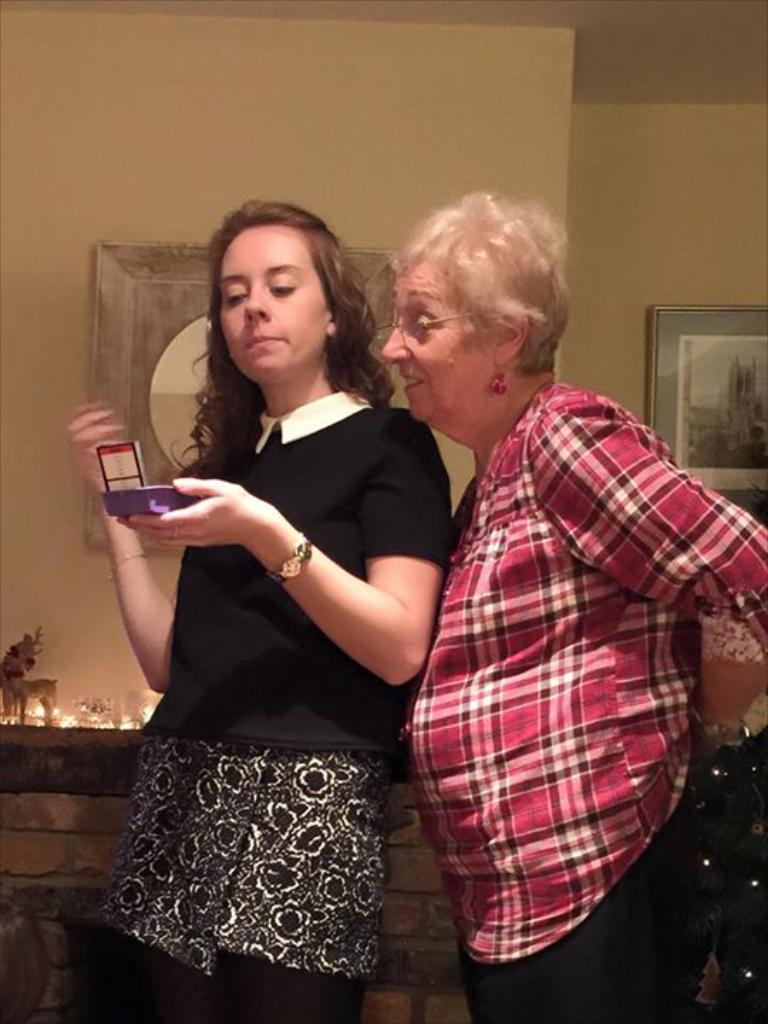How would you summarize this image in a sentence or two? Here we can see two women and she is holding an object with her hand. In the background we can see lights, toys, and frames on the wall. 